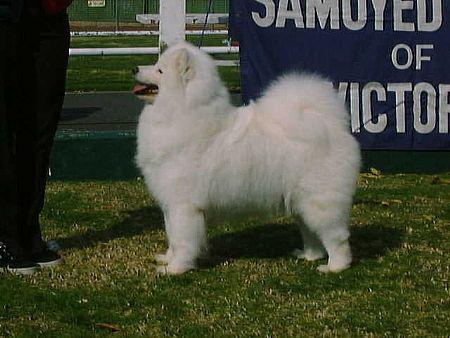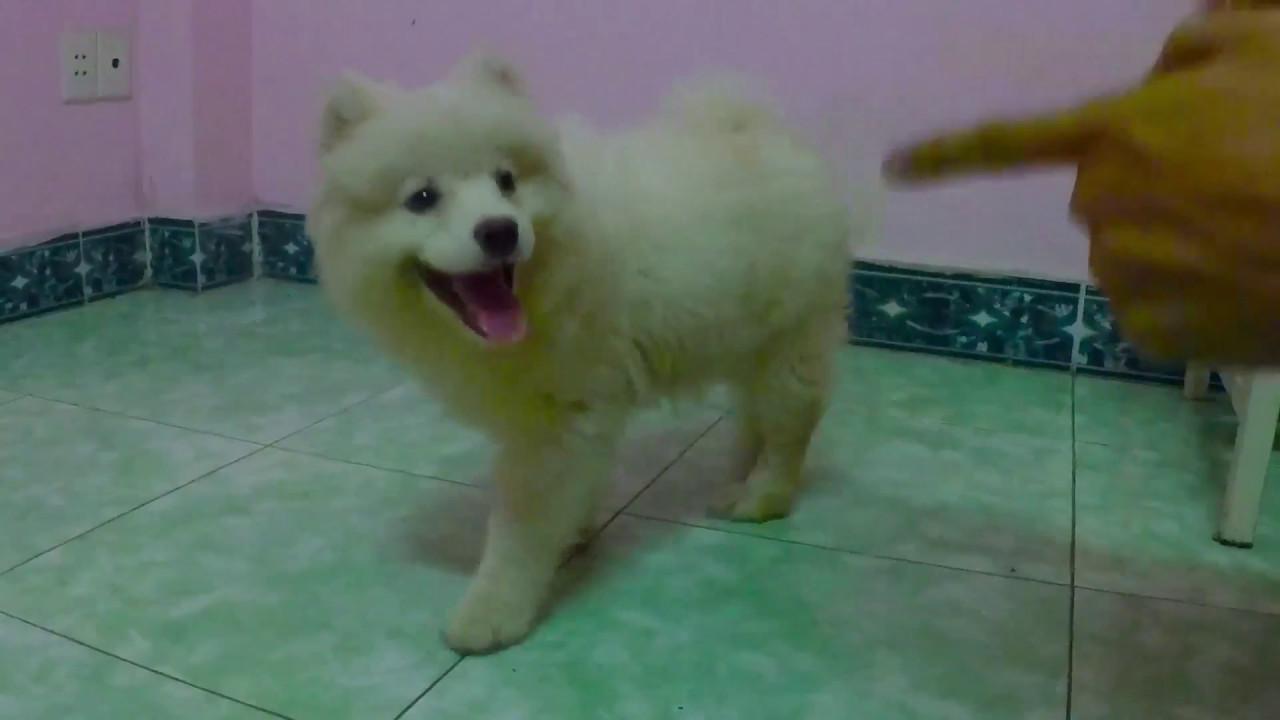The first image is the image on the left, the second image is the image on the right. Examine the images to the left and right. Is the description "At least one dog is in the snow." accurate? Answer yes or no. No. The first image is the image on the left, the second image is the image on the right. For the images displayed, is the sentence "there is at least one dog stading in the snow in the image pair" factually correct? Answer yes or no. No. 